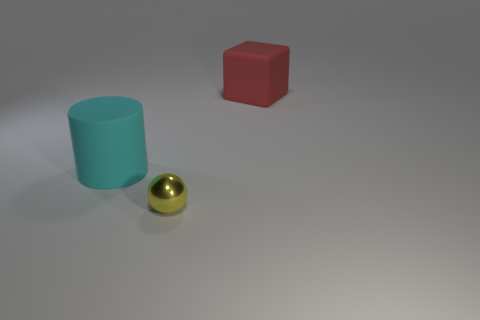How many tiny spheres are the same material as the cyan object?
Your answer should be very brief. 0. Is the big object left of the yellow metallic object made of the same material as the ball?
Make the answer very short. No. Are there an equal number of tiny metal spheres that are to the left of the large cyan cylinder and big purple shiny cubes?
Provide a succinct answer. Yes. The cylinder is what size?
Ensure brevity in your answer.  Large. How many spheres are the same color as the small shiny thing?
Give a very brief answer. 0. Is the size of the block the same as the cylinder?
Your answer should be very brief. Yes. What is the size of the matte thing that is in front of the big rubber object that is behind the big cyan cylinder?
Provide a succinct answer. Large. Does the large cube have the same color as the large matte thing left of the tiny yellow shiny sphere?
Your response must be concise. No. Are there any green matte cubes that have the same size as the metal ball?
Ensure brevity in your answer.  No. There is a matte object in front of the red rubber object; what is its size?
Keep it short and to the point. Large. 